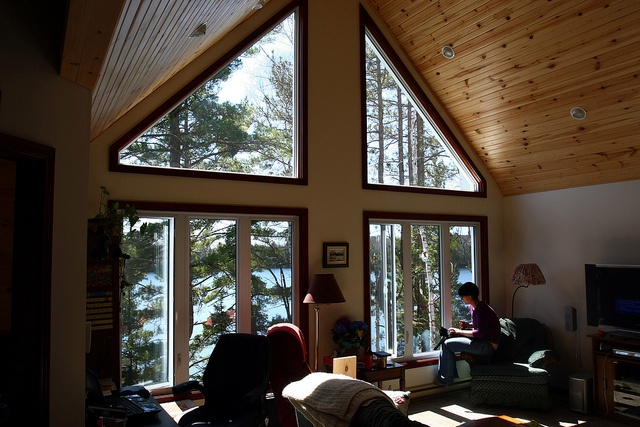Describe the objects in this image and their specific colors. I can see chair in black, gray, maroon, and white tones, chair in black, darkgray, lightgray, and gray tones, couch in black, white, and gray tones, chair in black, white, and gray tones, and tv in black tones in this image. 